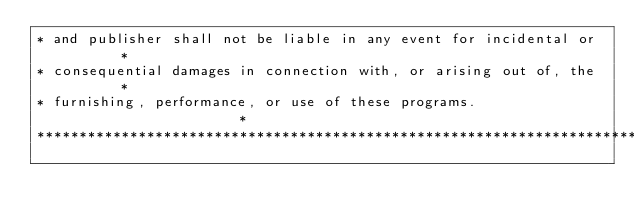<code> <loc_0><loc_0><loc_500><loc_500><_CSS_>* and publisher shall not be liable in any event for incidental or       *
* consequential damages in connection with, or arising out of, the       *
* furnishing, performance, or use of these programs.                     *
*************************************************************************/</code> 